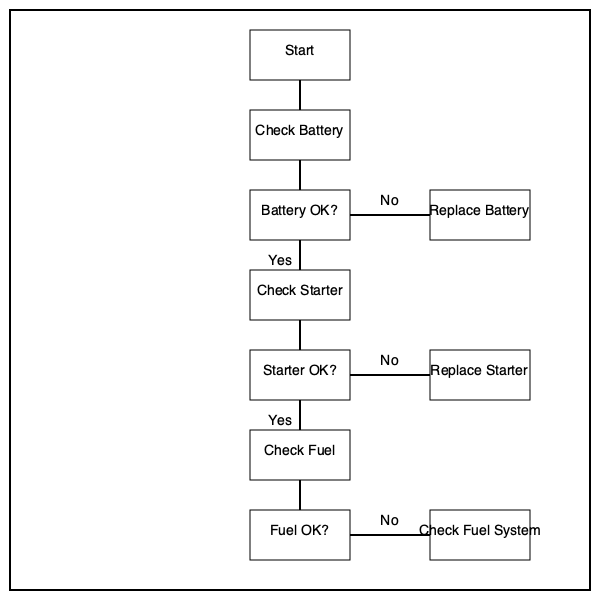According to the flowchart, if the battery and starter are both functioning correctly, but the engine still doesn't start, what should be checked next? Let's follow the flowchart step-by-step:

1. We start at the "Start" box.
2. The first check is "Check Battery".
3. We then ask "Battery OK?". In this case, we're told the battery is functioning correctly, so we follow the "Yes" path.
4. Next, we "Check Starter".
5. We then ask "Starter OK?". Again, we're told the starter is functioning correctly, so we follow the "Yes" path.
6. If both the battery and starter are OK, but the engine still doesn't start, we move to the next step in the flowchart.
7. The next step in the flowchart is "Check Fuel".

Therefore, according to this diagnostic flowchart, if the battery and starter are both functioning correctly but the engine still doesn't start, the next step is to check the fuel.
Answer: Check Fuel 